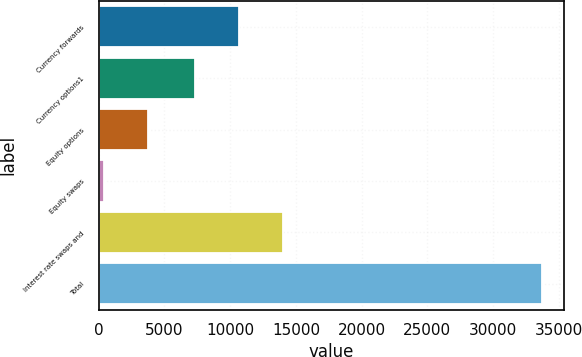Convert chart. <chart><loc_0><loc_0><loc_500><loc_500><bar_chart><fcel>Currency forwards<fcel>Currency options1<fcel>Equity options<fcel>Equity swaps<fcel>Interest rate swaps and<fcel>Total<nl><fcel>10690.4<fcel>7357<fcel>3725.4<fcel>392<fcel>14023.8<fcel>33726<nl></chart> 